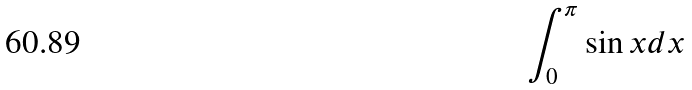<formula> <loc_0><loc_0><loc_500><loc_500>\int _ { 0 } ^ { \pi } \sin x d x</formula> 